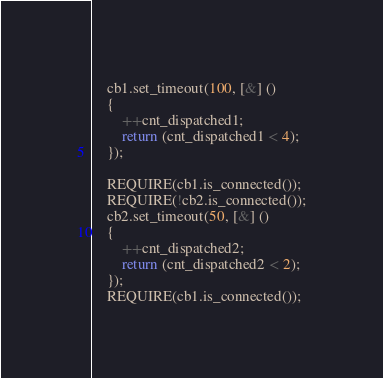Convert code to text. <code><loc_0><loc_0><loc_500><loc_500><_C++_>    cb1.set_timeout(100, [&] ()
    {
        ++cnt_dispatched1;
        return (cnt_dispatched1 < 4);
    });

    REQUIRE(cb1.is_connected());
    REQUIRE(!cb2.is_connected());
    cb2.set_timeout(50, [&] ()
    {
        ++cnt_dispatched2;
        return (cnt_dispatched2 < 2);
    });
    REQUIRE(cb1.is_connected());</code> 